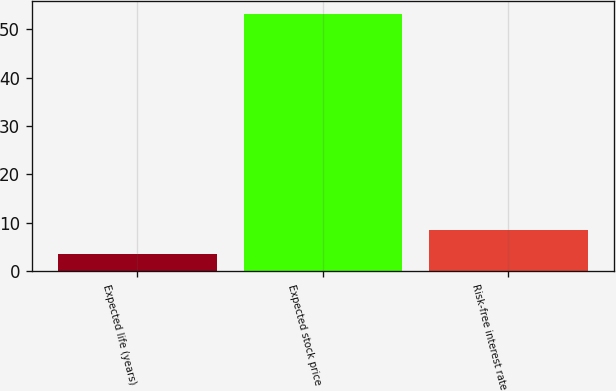Convert chart to OTSL. <chart><loc_0><loc_0><loc_500><loc_500><bar_chart><fcel>Expected life (years)<fcel>Expected stock price<fcel>Risk-free interest rate<nl><fcel>3.55<fcel>53.1<fcel>8.51<nl></chart> 